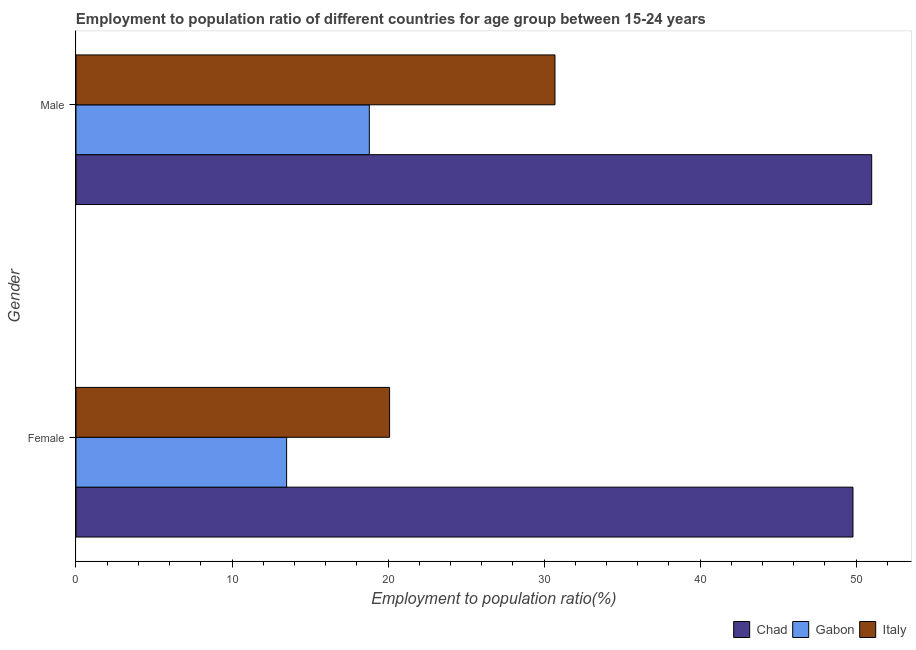How many different coloured bars are there?
Keep it short and to the point. 3. Are the number of bars per tick equal to the number of legend labels?
Your response must be concise. Yes. Are the number of bars on each tick of the Y-axis equal?
Keep it short and to the point. Yes. How many bars are there on the 2nd tick from the bottom?
Make the answer very short. 3. What is the label of the 2nd group of bars from the top?
Ensure brevity in your answer.  Female. What is the employment to population ratio(female) in Chad?
Provide a succinct answer. 49.8. Across all countries, what is the maximum employment to population ratio(male)?
Your response must be concise. 51. Across all countries, what is the minimum employment to population ratio(male)?
Your response must be concise. 18.8. In which country was the employment to population ratio(male) maximum?
Make the answer very short. Chad. In which country was the employment to population ratio(female) minimum?
Keep it short and to the point. Gabon. What is the total employment to population ratio(male) in the graph?
Your response must be concise. 100.5. What is the difference between the employment to population ratio(female) in Gabon and that in Chad?
Your response must be concise. -36.3. What is the difference between the employment to population ratio(male) in Chad and the employment to population ratio(female) in Italy?
Your answer should be very brief. 30.9. What is the average employment to population ratio(female) per country?
Offer a terse response. 27.8. What is the difference between the employment to population ratio(male) and employment to population ratio(female) in Chad?
Your answer should be very brief. 1.2. In how many countries, is the employment to population ratio(male) greater than 32 %?
Keep it short and to the point. 1. What is the ratio of the employment to population ratio(female) in Italy to that in Gabon?
Make the answer very short. 1.49. Is the employment to population ratio(female) in Chad less than that in Gabon?
Provide a succinct answer. No. In how many countries, is the employment to population ratio(female) greater than the average employment to population ratio(female) taken over all countries?
Your answer should be very brief. 1. What does the 3rd bar from the top in Female represents?
Your answer should be compact. Chad. What does the 2nd bar from the bottom in Male represents?
Make the answer very short. Gabon. What is the difference between two consecutive major ticks on the X-axis?
Provide a succinct answer. 10. Where does the legend appear in the graph?
Provide a short and direct response. Bottom right. How many legend labels are there?
Your response must be concise. 3. How are the legend labels stacked?
Provide a short and direct response. Horizontal. What is the title of the graph?
Offer a terse response. Employment to population ratio of different countries for age group between 15-24 years. Does "Lower middle income" appear as one of the legend labels in the graph?
Your answer should be compact. No. What is the label or title of the X-axis?
Provide a short and direct response. Employment to population ratio(%). What is the Employment to population ratio(%) in Chad in Female?
Offer a very short reply. 49.8. What is the Employment to population ratio(%) of Gabon in Female?
Provide a succinct answer. 13.5. What is the Employment to population ratio(%) of Italy in Female?
Your response must be concise. 20.1. What is the Employment to population ratio(%) of Gabon in Male?
Ensure brevity in your answer.  18.8. What is the Employment to population ratio(%) of Italy in Male?
Offer a very short reply. 30.7. Across all Gender, what is the maximum Employment to population ratio(%) of Gabon?
Give a very brief answer. 18.8. Across all Gender, what is the maximum Employment to population ratio(%) of Italy?
Make the answer very short. 30.7. Across all Gender, what is the minimum Employment to population ratio(%) in Chad?
Provide a short and direct response. 49.8. Across all Gender, what is the minimum Employment to population ratio(%) of Italy?
Give a very brief answer. 20.1. What is the total Employment to population ratio(%) of Chad in the graph?
Give a very brief answer. 100.8. What is the total Employment to population ratio(%) in Gabon in the graph?
Ensure brevity in your answer.  32.3. What is the total Employment to population ratio(%) of Italy in the graph?
Provide a short and direct response. 50.8. What is the difference between the Employment to population ratio(%) of Gabon in Female and that in Male?
Ensure brevity in your answer.  -5.3. What is the difference between the Employment to population ratio(%) in Chad in Female and the Employment to population ratio(%) in Italy in Male?
Make the answer very short. 19.1. What is the difference between the Employment to population ratio(%) of Gabon in Female and the Employment to population ratio(%) of Italy in Male?
Offer a very short reply. -17.2. What is the average Employment to population ratio(%) of Chad per Gender?
Offer a terse response. 50.4. What is the average Employment to population ratio(%) of Gabon per Gender?
Keep it short and to the point. 16.15. What is the average Employment to population ratio(%) of Italy per Gender?
Your response must be concise. 25.4. What is the difference between the Employment to population ratio(%) of Chad and Employment to population ratio(%) of Gabon in Female?
Offer a very short reply. 36.3. What is the difference between the Employment to population ratio(%) of Chad and Employment to population ratio(%) of Italy in Female?
Make the answer very short. 29.7. What is the difference between the Employment to population ratio(%) of Chad and Employment to population ratio(%) of Gabon in Male?
Provide a short and direct response. 32.2. What is the difference between the Employment to population ratio(%) of Chad and Employment to population ratio(%) of Italy in Male?
Your answer should be compact. 20.3. What is the difference between the Employment to population ratio(%) of Gabon and Employment to population ratio(%) of Italy in Male?
Ensure brevity in your answer.  -11.9. What is the ratio of the Employment to population ratio(%) of Chad in Female to that in Male?
Offer a very short reply. 0.98. What is the ratio of the Employment to population ratio(%) in Gabon in Female to that in Male?
Provide a short and direct response. 0.72. What is the ratio of the Employment to population ratio(%) of Italy in Female to that in Male?
Give a very brief answer. 0.65. What is the difference between the highest and the second highest Employment to population ratio(%) in Gabon?
Your answer should be compact. 5.3. What is the difference between the highest and the lowest Employment to population ratio(%) in Chad?
Make the answer very short. 1.2. What is the difference between the highest and the lowest Employment to population ratio(%) of Italy?
Offer a very short reply. 10.6. 